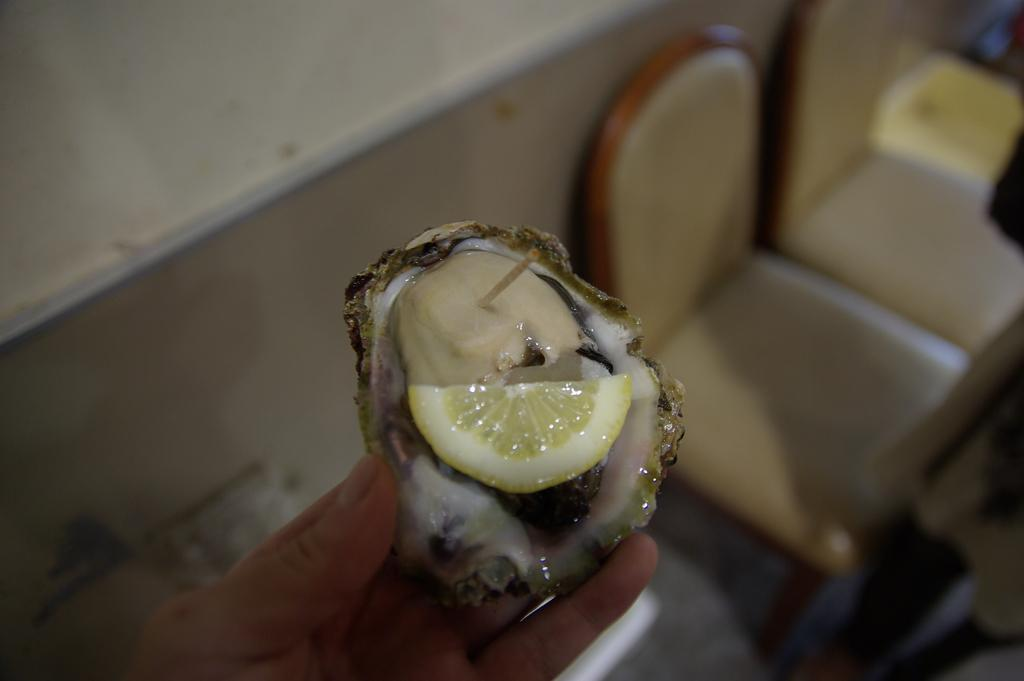What is the person's hand holding in the image? There is a person's hand holding a food item in the image. What type of furniture can be seen in the image? There are chairs in the image. What type of structure is visible in the image? There is a wall in the image. How many spiders are crawling on the wall in the image? There are no spiders visible in the image; only a wall is present. What type of bell can be heard ringing in the image? There is no bell present or audible in the image. 